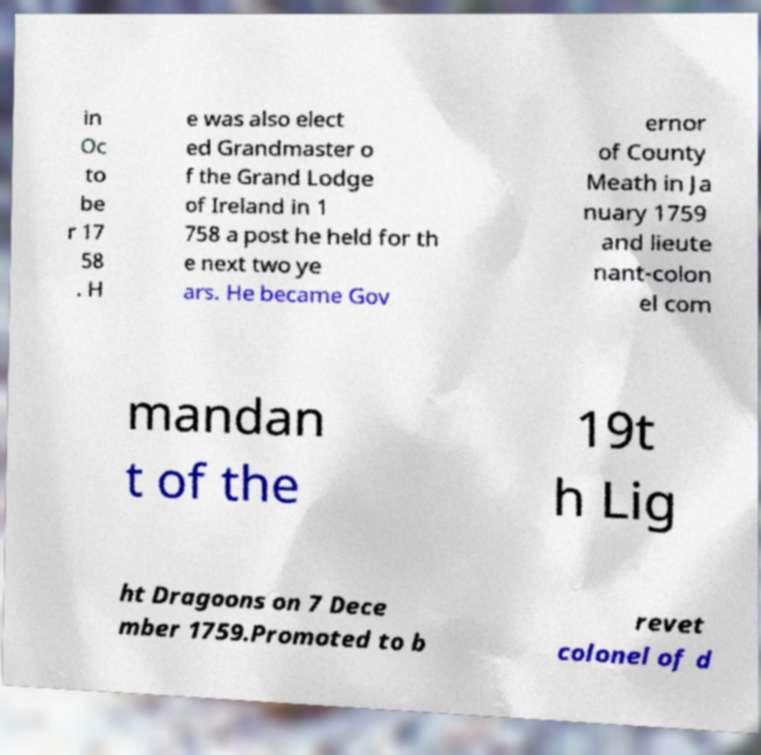For documentation purposes, I need the text within this image transcribed. Could you provide that? in Oc to be r 17 58 . H e was also elect ed Grandmaster o f the Grand Lodge of Ireland in 1 758 a post he held for th e next two ye ars. He became Gov ernor of County Meath in Ja nuary 1759 and lieute nant-colon el com mandan t of the 19t h Lig ht Dragoons on 7 Dece mber 1759.Promoted to b revet colonel of d 